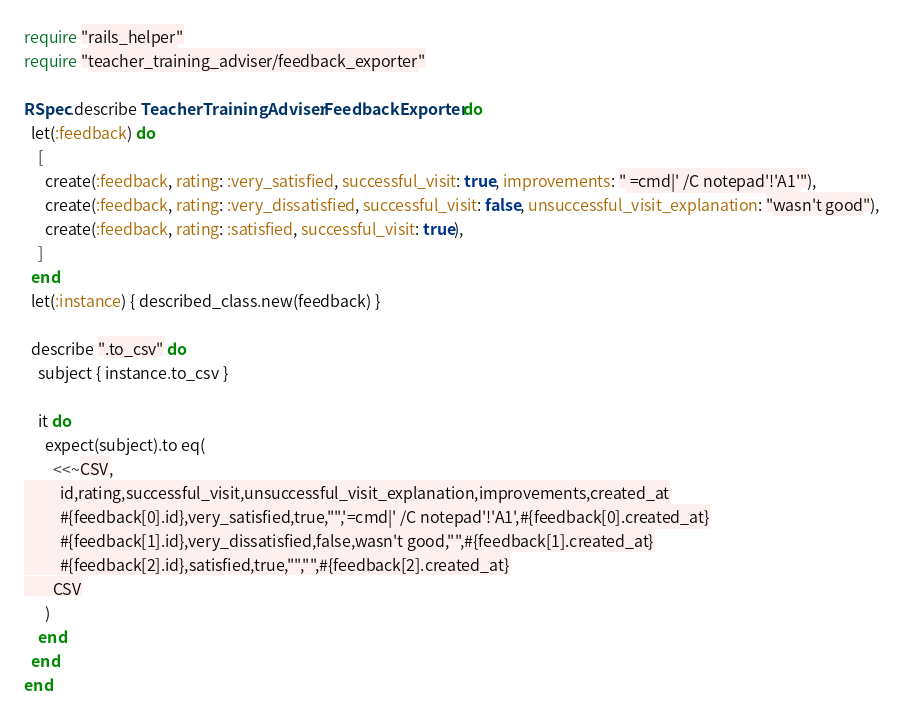Convert code to text. <code><loc_0><loc_0><loc_500><loc_500><_Ruby_>require "rails_helper"
require "teacher_training_adviser/feedback_exporter"

RSpec.describe TeacherTrainingAdviser::FeedbackExporter do
  let(:feedback) do
    [
      create(:feedback, rating: :very_satisfied, successful_visit: true, improvements: " =cmd|' /C notepad'!'A1'"),
      create(:feedback, rating: :very_dissatisfied, successful_visit: false, unsuccessful_visit_explanation: "wasn't good"),
      create(:feedback, rating: :satisfied, successful_visit: true),
    ]
  end
  let(:instance) { described_class.new(feedback) }

  describe ".to_csv" do
    subject { instance.to_csv }

    it do
      expect(subject).to eq(
        <<~CSV,
          id,rating,successful_visit,unsuccessful_visit_explanation,improvements,created_at
          #{feedback[0].id},very_satisfied,true,"",'=cmd|' /C notepad'!'A1',#{feedback[0].created_at}
          #{feedback[1].id},very_dissatisfied,false,wasn't good,"",#{feedback[1].created_at}
          #{feedback[2].id},satisfied,true,"","",#{feedback[2].created_at}
        CSV
      )
    end
  end
end
</code> 